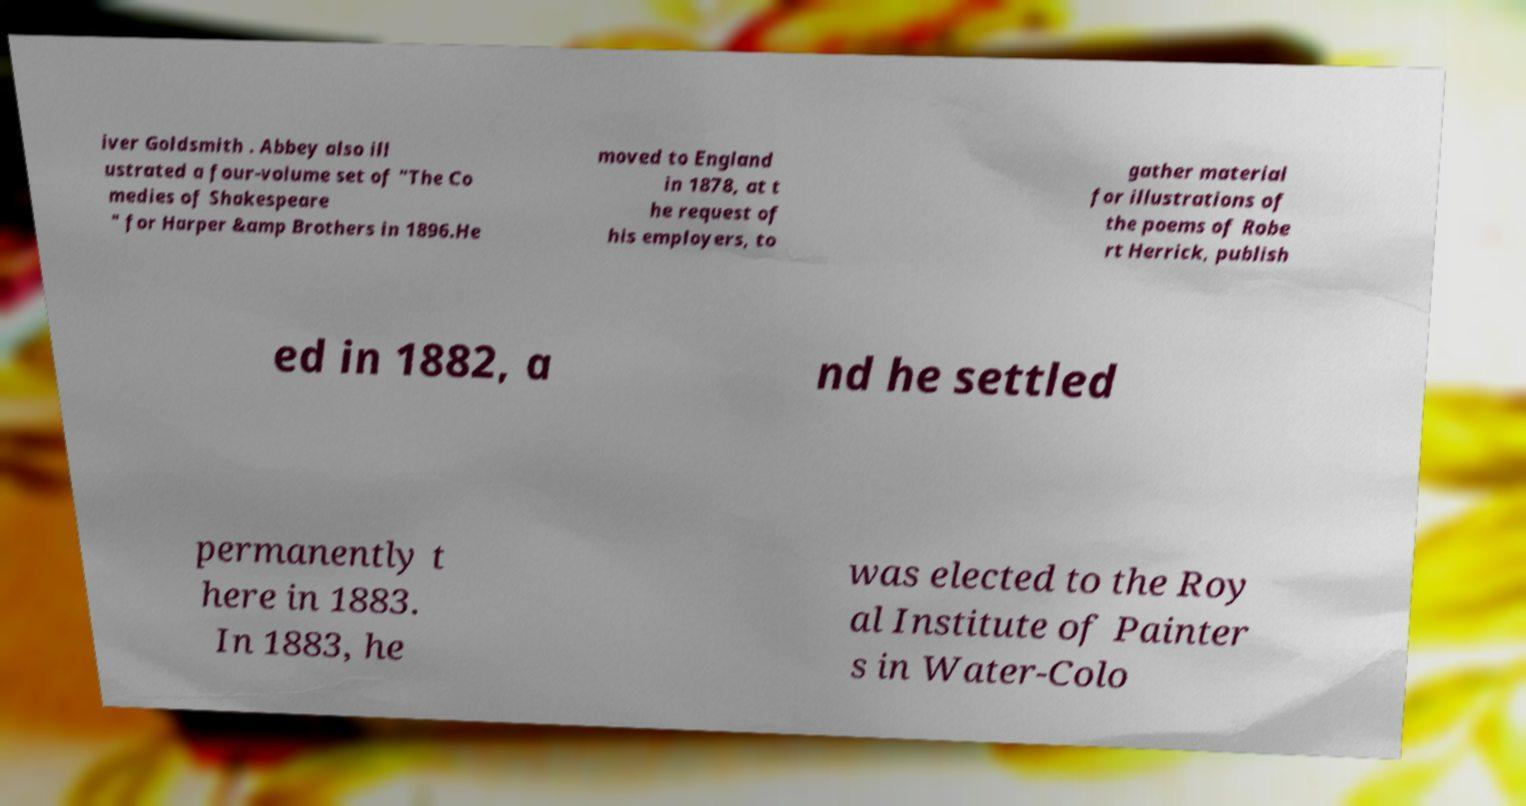For documentation purposes, I need the text within this image transcribed. Could you provide that? iver Goldsmith . Abbey also ill ustrated a four-volume set of "The Co medies of Shakespeare " for Harper &amp Brothers in 1896.He moved to England in 1878, at t he request of his employers, to gather material for illustrations of the poems of Robe rt Herrick, publish ed in 1882, a nd he settled permanently t here in 1883. In 1883, he was elected to the Roy al Institute of Painter s in Water-Colo 